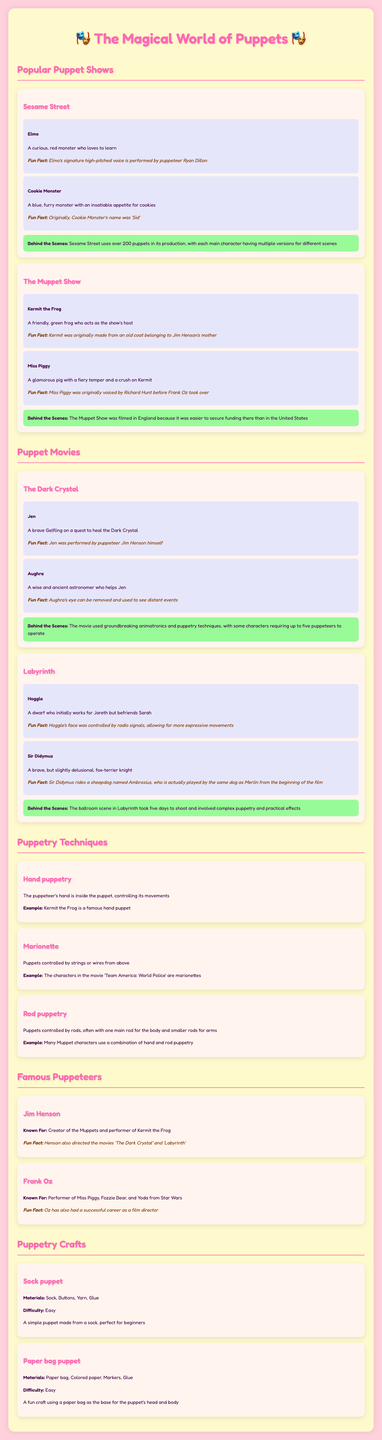What is the name of the red monster from Sesame Street? Elmo is identified as the curious red monster in the character profiles under Sesame Street.
Answer: Elmo Who performed Kermit's voice? Jim Henson is noted as the creator and performer of Kermit the Frog, as stated in the famous puppeteers section.
Answer: Jim Henson How many versions of each main character are used in Sesame Street? The document mentions that Sesame Street uses over 200 puppets, indicating multiple versions for different scenes.
Answer: Over 200 Which character helps Jen in The Dark Crystal? Aughra is mentioned as the wise character who assists Jen in the movie section.
Answer: Aughra What type of puppetry involves control from above with strings? The document defines Marionette as the type of puppetry controlled by strings or wires from above.
Answer: Marionette Which puppet character has an insatiable appetite for cookies? Cookie Monster is described in the character profiles as the blue furry monster with an appetite for cookies.
Answer: Cookie Monster What material is used to make a sock puppet? The puppetry crafts section lists "Sock" among the materials needed to create a sock puppet.
Answer: Sock How long did the ballroom scene in Labyrinth take to shoot? The documentary notes that the ballroom scene took five days to shoot according to the behind-the-scenes information in the movie section.
Answer: Five days Who directed The Dark Crystal and Labyrinth? Jim Henson is noted as the director for both movies in the famous puppeteers section.
Answer: Jim Henson 